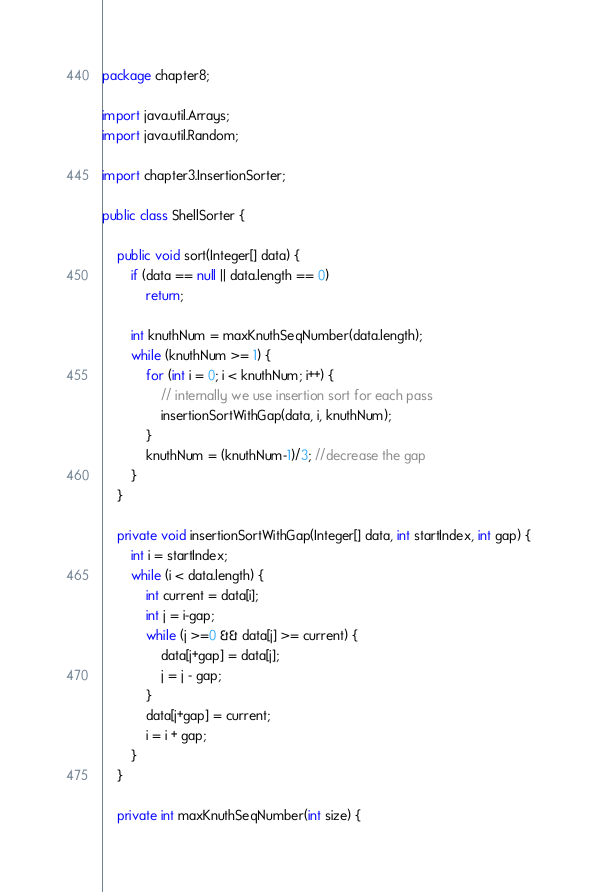<code> <loc_0><loc_0><loc_500><loc_500><_Java_>package chapter8;

import java.util.Arrays;
import java.util.Random;

import chapter3.InsertionSorter;

public class ShellSorter {
	
	public void sort(Integer[] data) {
		if (data == null || data.length == 0)
			return;
		
		int knuthNum = maxKnuthSeqNumber(data.length);
		while (knuthNum >= 1) {
			for (int i = 0; i < knuthNum; i++) {
				// internally we use insertion sort for each pass
				insertionSortWithGap(data, i, knuthNum);
			}
			knuthNum = (knuthNum-1)/3; //decrease the gap
		}
	}
	
	private void insertionSortWithGap(Integer[] data, int startIndex, int gap) {
		int i = startIndex;
		while (i < data.length) {
			int current = data[i];
			int j = i-gap;
			while (j >=0 && data[j] >= current) {
				data[j+gap] = data[j];
				j = j - gap;
			}
			data[j+gap] = current;
			i = i + gap;
		}
	}
	
	private int maxKnuthSeqNumber(int size) {</code> 